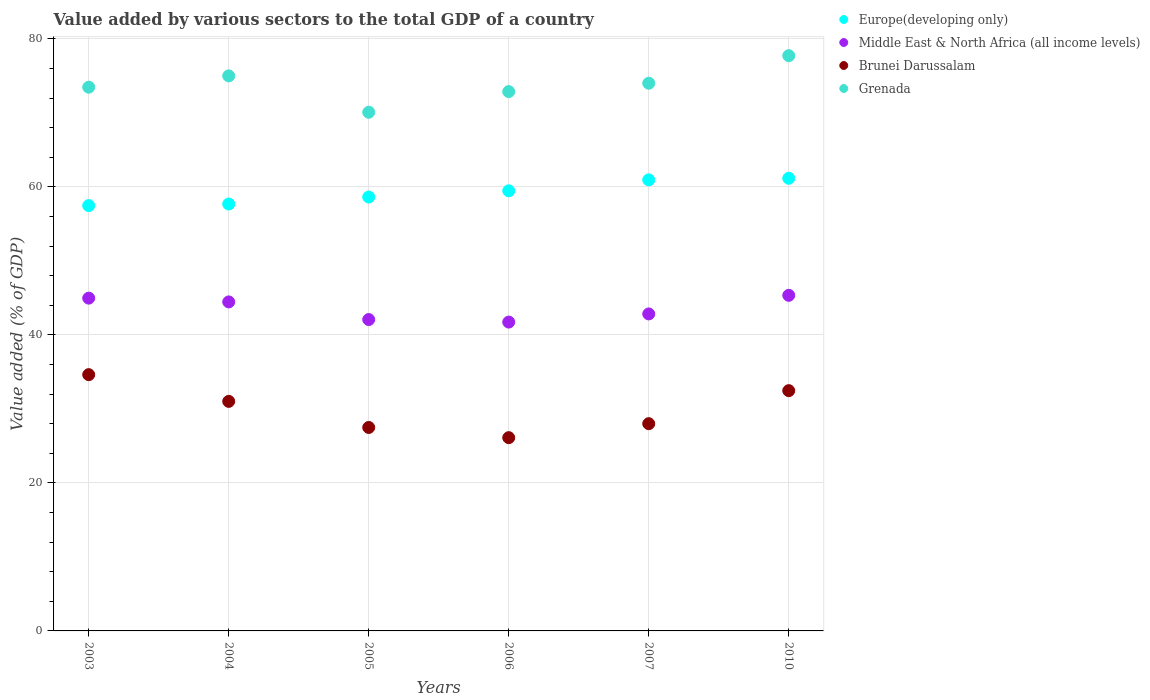Is the number of dotlines equal to the number of legend labels?
Make the answer very short. Yes. What is the value added by various sectors to the total GDP in Middle East & North Africa (all income levels) in 2007?
Your answer should be compact. 42.84. Across all years, what is the maximum value added by various sectors to the total GDP in Middle East & North Africa (all income levels)?
Offer a terse response. 45.35. Across all years, what is the minimum value added by various sectors to the total GDP in Europe(developing only)?
Make the answer very short. 57.48. In which year was the value added by various sectors to the total GDP in Grenada minimum?
Your answer should be very brief. 2005. What is the total value added by various sectors to the total GDP in Europe(developing only) in the graph?
Keep it short and to the point. 355.39. What is the difference between the value added by various sectors to the total GDP in Grenada in 2004 and that in 2006?
Give a very brief answer. 2.12. What is the difference between the value added by various sectors to the total GDP in Brunei Darussalam in 2003 and the value added by various sectors to the total GDP in Grenada in 2005?
Keep it short and to the point. -35.46. What is the average value added by various sectors to the total GDP in Grenada per year?
Keep it short and to the point. 73.87. In the year 2007, what is the difference between the value added by various sectors to the total GDP in Grenada and value added by various sectors to the total GDP in Europe(developing only)?
Give a very brief answer. 13.06. What is the ratio of the value added by various sectors to the total GDP in Middle East & North Africa (all income levels) in 2003 to that in 2005?
Offer a very short reply. 1.07. What is the difference between the highest and the second highest value added by various sectors to the total GDP in Europe(developing only)?
Make the answer very short. 0.21. What is the difference between the highest and the lowest value added by various sectors to the total GDP in Europe(developing only)?
Provide a succinct answer. 3.69. In how many years, is the value added by various sectors to the total GDP in Grenada greater than the average value added by various sectors to the total GDP in Grenada taken over all years?
Provide a short and direct response. 3. Is the sum of the value added by various sectors to the total GDP in Middle East & North Africa (all income levels) in 2005 and 2006 greater than the maximum value added by various sectors to the total GDP in Brunei Darussalam across all years?
Make the answer very short. Yes. Is it the case that in every year, the sum of the value added by various sectors to the total GDP in Brunei Darussalam and value added by various sectors to the total GDP in Europe(developing only)  is greater than the value added by various sectors to the total GDP in Middle East & North Africa (all income levels)?
Give a very brief answer. Yes. Is the value added by various sectors to the total GDP in Brunei Darussalam strictly greater than the value added by various sectors to the total GDP in Grenada over the years?
Provide a short and direct response. No. Is the value added by various sectors to the total GDP in Middle East & North Africa (all income levels) strictly less than the value added by various sectors to the total GDP in Brunei Darussalam over the years?
Offer a very short reply. No. How many dotlines are there?
Your answer should be very brief. 4. Are the values on the major ticks of Y-axis written in scientific E-notation?
Provide a succinct answer. No. Does the graph contain grids?
Your answer should be compact. Yes. Where does the legend appear in the graph?
Provide a succinct answer. Top right. How many legend labels are there?
Your answer should be very brief. 4. What is the title of the graph?
Provide a succinct answer. Value added by various sectors to the total GDP of a country. What is the label or title of the X-axis?
Provide a succinct answer. Years. What is the label or title of the Y-axis?
Provide a succinct answer. Value added (% of GDP). What is the Value added (% of GDP) in Europe(developing only) in 2003?
Offer a very short reply. 57.48. What is the Value added (% of GDP) of Middle East & North Africa (all income levels) in 2003?
Provide a short and direct response. 44.97. What is the Value added (% of GDP) in Brunei Darussalam in 2003?
Your response must be concise. 34.63. What is the Value added (% of GDP) of Grenada in 2003?
Your answer should be compact. 73.48. What is the Value added (% of GDP) of Europe(developing only) in 2004?
Keep it short and to the point. 57.69. What is the Value added (% of GDP) in Middle East & North Africa (all income levels) in 2004?
Provide a short and direct response. 44.46. What is the Value added (% of GDP) in Brunei Darussalam in 2004?
Make the answer very short. 31.02. What is the Value added (% of GDP) in Grenada in 2004?
Your answer should be compact. 75. What is the Value added (% of GDP) of Europe(developing only) in 2005?
Provide a succinct answer. 58.63. What is the Value added (% of GDP) in Middle East & North Africa (all income levels) in 2005?
Provide a short and direct response. 42.08. What is the Value added (% of GDP) in Brunei Darussalam in 2005?
Offer a very short reply. 27.49. What is the Value added (% of GDP) in Grenada in 2005?
Your answer should be compact. 70.09. What is the Value added (% of GDP) of Europe(developing only) in 2006?
Ensure brevity in your answer.  59.47. What is the Value added (% of GDP) of Middle East & North Africa (all income levels) in 2006?
Ensure brevity in your answer.  41.73. What is the Value added (% of GDP) of Brunei Darussalam in 2006?
Your answer should be very brief. 26.12. What is the Value added (% of GDP) in Grenada in 2006?
Make the answer very short. 72.88. What is the Value added (% of GDP) in Europe(developing only) in 2007?
Your response must be concise. 60.95. What is the Value added (% of GDP) of Middle East & North Africa (all income levels) in 2007?
Your answer should be very brief. 42.84. What is the Value added (% of GDP) of Brunei Darussalam in 2007?
Your answer should be compact. 28.01. What is the Value added (% of GDP) of Grenada in 2007?
Keep it short and to the point. 74.01. What is the Value added (% of GDP) in Europe(developing only) in 2010?
Make the answer very short. 61.17. What is the Value added (% of GDP) in Middle East & North Africa (all income levels) in 2010?
Make the answer very short. 45.35. What is the Value added (% of GDP) in Brunei Darussalam in 2010?
Provide a succinct answer. 32.47. What is the Value added (% of GDP) of Grenada in 2010?
Provide a succinct answer. 77.73. Across all years, what is the maximum Value added (% of GDP) of Europe(developing only)?
Your answer should be compact. 61.17. Across all years, what is the maximum Value added (% of GDP) in Middle East & North Africa (all income levels)?
Your answer should be compact. 45.35. Across all years, what is the maximum Value added (% of GDP) of Brunei Darussalam?
Your answer should be compact. 34.63. Across all years, what is the maximum Value added (% of GDP) of Grenada?
Your answer should be compact. 77.73. Across all years, what is the minimum Value added (% of GDP) in Europe(developing only)?
Offer a terse response. 57.48. Across all years, what is the minimum Value added (% of GDP) in Middle East & North Africa (all income levels)?
Ensure brevity in your answer.  41.73. Across all years, what is the minimum Value added (% of GDP) of Brunei Darussalam?
Your answer should be compact. 26.12. Across all years, what is the minimum Value added (% of GDP) in Grenada?
Offer a very short reply. 70.09. What is the total Value added (% of GDP) of Europe(developing only) in the graph?
Offer a terse response. 355.39. What is the total Value added (% of GDP) of Middle East & North Africa (all income levels) in the graph?
Provide a short and direct response. 261.43. What is the total Value added (% of GDP) in Brunei Darussalam in the graph?
Your answer should be very brief. 179.73. What is the total Value added (% of GDP) in Grenada in the graph?
Your answer should be very brief. 443.19. What is the difference between the Value added (% of GDP) of Europe(developing only) in 2003 and that in 2004?
Provide a short and direct response. -0.21. What is the difference between the Value added (% of GDP) in Middle East & North Africa (all income levels) in 2003 and that in 2004?
Your answer should be compact. 0.51. What is the difference between the Value added (% of GDP) of Brunei Darussalam in 2003 and that in 2004?
Provide a short and direct response. 3.61. What is the difference between the Value added (% of GDP) in Grenada in 2003 and that in 2004?
Give a very brief answer. -1.53. What is the difference between the Value added (% of GDP) in Europe(developing only) in 2003 and that in 2005?
Give a very brief answer. -1.16. What is the difference between the Value added (% of GDP) of Middle East & North Africa (all income levels) in 2003 and that in 2005?
Make the answer very short. 2.89. What is the difference between the Value added (% of GDP) of Brunei Darussalam in 2003 and that in 2005?
Make the answer very short. 7.14. What is the difference between the Value added (% of GDP) of Grenada in 2003 and that in 2005?
Your answer should be very brief. 3.39. What is the difference between the Value added (% of GDP) of Europe(developing only) in 2003 and that in 2006?
Keep it short and to the point. -2. What is the difference between the Value added (% of GDP) of Middle East & North Africa (all income levels) in 2003 and that in 2006?
Your response must be concise. 3.24. What is the difference between the Value added (% of GDP) in Brunei Darussalam in 2003 and that in 2006?
Keep it short and to the point. 8.51. What is the difference between the Value added (% of GDP) in Grenada in 2003 and that in 2006?
Provide a succinct answer. 0.6. What is the difference between the Value added (% of GDP) in Europe(developing only) in 2003 and that in 2007?
Your answer should be very brief. -3.48. What is the difference between the Value added (% of GDP) in Middle East & North Africa (all income levels) in 2003 and that in 2007?
Offer a very short reply. 2.13. What is the difference between the Value added (% of GDP) in Brunei Darussalam in 2003 and that in 2007?
Make the answer very short. 6.62. What is the difference between the Value added (% of GDP) of Grenada in 2003 and that in 2007?
Offer a very short reply. -0.53. What is the difference between the Value added (% of GDP) of Europe(developing only) in 2003 and that in 2010?
Provide a succinct answer. -3.69. What is the difference between the Value added (% of GDP) of Middle East & North Africa (all income levels) in 2003 and that in 2010?
Keep it short and to the point. -0.38. What is the difference between the Value added (% of GDP) in Brunei Darussalam in 2003 and that in 2010?
Offer a very short reply. 2.16. What is the difference between the Value added (% of GDP) of Grenada in 2003 and that in 2010?
Ensure brevity in your answer.  -4.26. What is the difference between the Value added (% of GDP) in Europe(developing only) in 2004 and that in 2005?
Offer a terse response. -0.95. What is the difference between the Value added (% of GDP) of Middle East & North Africa (all income levels) in 2004 and that in 2005?
Keep it short and to the point. 2.38. What is the difference between the Value added (% of GDP) in Brunei Darussalam in 2004 and that in 2005?
Ensure brevity in your answer.  3.53. What is the difference between the Value added (% of GDP) in Grenada in 2004 and that in 2005?
Your response must be concise. 4.92. What is the difference between the Value added (% of GDP) of Europe(developing only) in 2004 and that in 2006?
Make the answer very short. -1.79. What is the difference between the Value added (% of GDP) of Middle East & North Africa (all income levels) in 2004 and that in 2006?
Give a very brief answer. 2.73. What is the difference between the Value added (% of GDP) of Brunei Darussalam in 2004 and that in 2006?
Your answer should be compact. 4.9. What is the difference between the Value added (% of GDP) in Grenada in 2004 and that in 2006?
Keep it short and to the point. 2.12. What is the difference between the Value added (% of GDP) of Europe(developing only) in 2004 and that in 2007?
Your response must be concise. -3.27. What is the difference between the Value added (% of GDP) in Middle East & North Africa (all income levels) in 2004 and that in 2007?
Offer a very short reply. 1.62. What is the difference between the Value added (% of GDP) of Brunei Darussalam in 2004 and that in 2007?
Make the answer very short. 3.01. What is the difference between the Value added (% of GDP) in Europe(developing only) in 2004 and that in 2010?
Offer a very short reply. -3.48. What is the difference between the Value added (% of GDP) in Middle East & North Africa (all income levels) in 2004 and that in 2010?
Make the answer very short. -0.89. What is the difference between the Value added (% of GDP) of Brunei Darussalam in 2004 and that in 2010?
Make the answer very short. -1.45. What is the difference between the Value added (% of GDP) in Grenada in 2004 and that in 2010?
Ensure brevity in your answer.  -2.73. What is the difference between the Value added (% of GDP) in Europe(developing only) in 2005 and that in 2006?
Your answer should be very brief. -0.84. What is the difference between the Value added (% of GDP) of Middle East & North Africa (all income levels) in 2005 and that in 2006?
Keep it short and to the point. 0.34. What is the difference between the Value added (% of GDP) in Brunei Darussalam in 2005 and that in 2006?
Offer a very short reply. 1.38. What is the difference between the Value added (% of GDP) in Grenada in 2005 and that in 2006?
Offer a terse response. -2.79. What is the difference between the Value added (% of GDP) of Europe(developing only) in 2005 and that in 2007?
Provide a short and direct response. -2.32. What is the difference between the Value added (% of GDP) in Middle East & North Africa (all income levels) in 2005 and that in 2007?
Provide a succinct answer. -0.76. What is the difference between the Value added (% of GDP) in Brunei Darussalam in 2005 and that in 2007?
Make the answer very short. -0.51. What is the difference between the Value added (% of GDP) of Grenada in 2005 and that in 2007?
Give a very brief answer. -3.92. What is the difference between the Value added (% of GDP) in Europe(developing only) in 2005 and that in 2010?
Your answer should be very brief. -2.53. What is the difference between the Value added (% of GDP) in Middle East & North Africa (all income levels) in 2005 and that in 2010?
Keep it short and to the point. -3.27. What is the difference between the Value added (% of GDP) of Brunei Darussalam in 2005 and that in 2010?
Your response must be concise. -4.97. What is the difference between the Value added (% of GDP) of Grenada in 2005 and that in 2010?
Ensure brevity in your answer.  -7.65. What is the difference between the Value added (% of GDP) of Europe(developing only) in 2006 and that in 2007?
Provide a short and direct response. -1.48. What is the difference between the Value added (% of GDP) in Middle East & North Africa (all income levels) in 2006 and that in 2007?
Your answer should be compact. -1.1. What is the difference between the Value added (% of GDP) of Brunei Darussalam in 2006 and that in 2007?
Keep it short and to the point. -1.89. What is the difference between the Value added (% of GDP) in Grenada in 2006 and that in 2007?
Provide a succinct answer. -1.13. What is the difference between the Value added (% of GDP) of Europe(developing only) in 2006 and that in 2010?
Ensure brevity in your answer.  -1.69. What is the difference between the Value added (% of GDP) in Middle East & North Africa (all income levels) in 2006 and that in 2010?
Your answer should be compact. -3.62. What is the difference between the Value added (% of GDP) of Brunei Darussalam in 2006 and that in 2010?
Your answer should be compact. -6.35. What is the difference between the Value added (% of GDP) in Grenada in 2006 and that in 2010?
Keep it short and to the point. -4.85. What is the difference between the Value added (% of GDP) in Europe(developing only) in 2007 and that in 2010?
Make the answer very short. -0.21. What is the difference between the Value added (% of GDP) in Middle East & North Africa (all income levels) in 2007 and that in 2010?
Keep it short and to the point. -2.51. What is the difference between the Value added (% of GDP) of Brunei Darussalam in 2007 and that in 2010?
Offer a terse response. -4.46. What is the difference between the Value added (% of GDP) of Grenada in 2007 and that in 2010?
Your answer should be very brief. -3.72. What is the difference between the Value added (% of GDP) in Europe(developing only) in 2003 and the Value added (% of GDP) in Middle East & North Africa (all income levels) in 2004?
Offer a very short reply. 13.02. What is the difference between the Value added (% of GDP) in Europe(developing only) in 2003 and the Value added (% of GDP) in Brunei Darussalam in 2004?
Provide a succinct answer. 26.46. What is the difference between the Value added (% of GDP) of Europe(developing only) in 2003 and the Value added (% of GDP) of Grenada in 2004?
Your answer should be very brief. -17.53. What is the difference between the Value added (% of GDP) of Middle East & North Africa (all income levels) in 2003 and the Value added (% of GDP) of Brunei Darussalam in 2004?
Ensure brevity in your answer.  13.95. What is the difference between the Value added (% of GDP) in Middle East & North Africa (all income levels) in 2003 and the Value added (% of GDP) in Grenada in 2004?
Make the answer very short. -30.03. What is the difference between the Value added (% of GDP) of Brunei Darussalam in 2003 and the Value added (% of GDP) of Grenada in 2004?
Offer a very short reply. -40.37. What is the difference between the Value added (% of GDP) in Europe(developing only) in 2003 and the Value added (% of GDP) in Middle East & North Africa (all income levels) in 2005?
Ensure brevity in your answer.  15.4. What is the difference between the Value added (% of GDP) in Europe(developing only) in 2003 and the Value added (% of GDP) in Brunei Darussalam in 2005?
Your answer should be compact. 29.98. What is the difference between the Value added (% of GDP) of Europe(developing only) in 2003 and the Value added (% of GDP) of Grenada in 2005?
Your answer should be very brief. -12.61. What is the difference between the Value added (% of GDP) in Middle East & North Africa (all income levels) in 2003 and the Value added (% of GDP) in Brunei Darussalam in 2005?
Your response must be concise. 17.48. What is the difference between the Value added (% of GDP) in Middle East & North Africa (all income levels) in 2003 and the Value added (% of GDP) in Grenada in 2005?
Ensure brevity in your answer.  -25.12. What is the difference between the Value added (% of GDP) in Brunei Darussalam in 2003 and the Value added (% of GDP) in Grenada in 2005?
Keep it short and to the point. -35.46. What is the difference between the Value added (% of GDP) in Europe(developing only) in 2003 and the Value added (% of GDP) in Middle East & North Africa (all income levels) in 2006?
Offer a very short reply. 15.74. What is the difference between the Value added (% of GDP) in Europe(developing only) in 2003 and the Value added (% of GDP) in Brunei Darussalam in 2006?
Your answer should be very brief. 31.36. What is the difference between the Value added (% of GDP) of Europe(developing only) in 2003 and the Value added (% of GDP) of Grenada in 2006?
Provide a short and direct response. -15.4. What is the difference between the Value added (% of GDP) in Middle East & North Africa (all income levels) in 2003 and the Value added (% of GDP) in Brunei Darussalam in 2006?
Offer a terse response. 18.85. What is the difference between the Value added (% of GDP) of Middle East & North Africa (all income levels) in 2003 and the Value added (% of GDP) of Grenada in 2006?
Ensure brevity in your answer.  -27.91. What is the difference between the Value added (% of GDP) in Brunei Darussalam in 2003 and the Value added (% of GDP) in Grenada in 2006?
Ensure brevity in your answer.  -38.25. What is the difference between the Value added (% of GDP) of Europe(developing only) in 2003 and the Value added (% of GDP) of Middle East & North Africa (all income levels) in 2007?
Your answer should be compact. 14.64. What is the difference between the Value added (% of GDP) of Europe(developing only) in 2003 and the Value added (% of GDP) of Brunei Darussalam in 2007?
Make the answer very short. 29.47. What is the difference between the Value added (% of GDP) in Europe(developing only) in 2003 and the Value added (% of GDP) in Grenada in 2007?
Keep it short and to the point. -16.53. What is the difference between the Value added (% of GDP) of Middle East & North Africa (all income levels) in 2003 and the Value added (% of GDP) of Brunei Darussalam in 2007?
Make the answer very short. 16.96. What is the difference between the Value added (% of GDP) in Middle East & North Africa (all income levels) in 2003 and the Value added (% of GDP) in Grenada in 2007?
Your answer should be very brief. -29.04. What is the difference between the Value added (% of GDP) of Brunei Darussalam in 2003 and the Value added (% of GDP) of Grenada in 2007?
Make the answer very short. -39.38. What is the difference between the Value added (% of GDP) of Europe(developing only) in 2003 and the Value added (% of GDP) of Middle East & North Africa (all income levels) in 2010?
Your response must be concise. 12.13. What is the difference between the Value added (% of GDP) of Europe(developing only) in 2003 and the Value added (% of GDP) of Brunei Darussalam in 2010?
Keep it short and to the point. 25.01. What is the difference between the Value added (% of GDP) in Europe(developing only) in 2003 and the Value added (% of GDP) in Grenada in 2010?
Your answer should be very brief. -20.26. What is the difference between the Value added (% of GDP) in Middle East & North Africa (all income levels) in 2003 and the Value added (% of GDP) in Brunei Darussalam in 2010?
Keep it short and to the point. 12.5. What is the difference between the Value added (% of GDP) in Middle East & North Africa (all income levels) in 2003 and the Value added (% of GDP) in Grenada in 2010?
Your answer should be compact. -32.77. What is the difference between the Value added (% of GDP) of Brunei Darussalam in 2003 and the Value added (% of GDP) of Grenada in 2010?
Offer a very short reply. -43.1. What is the difference between the Value added (% of GDP) of Europe(developing only) in 2004 and the Value added (% of GDP) of Middle East & North Africa (all income levels) in 2005?
Offer a terse response. 15.61. What is the difference between the Value added (% of GDP) of Europe(developing only) in 2004 and the Value added (% of GDP) of Brunei Darussalam in 2005?
Make the answer very short. 30.19. What is the difference between the Value added (% of GDP) in Europe(developing only) in 2004 and the Value added (% of GDP) in Grenada in 2005?
Your answer should be compact. -12.4. What is the difference between the Value added (% of GDP) of Middle East & North Africa (all income levels) in 2004 and the Value added (% of GDP) of Brunei Darussalam in 2005?
Give a very brief answer. 16.97. What is the difference between the Value added (% of GDP) in Middle East & North Africa (all income levels) in 2004 and the Value added (% of GDP) in Grenada in 2005?
Your answer should be very brief. -25.63. What is the difference between the Value added (% of GDP) of Brunei Darussalam in 2004 and the Value added (% of GDP) of Grenada in 2005?
Make the answer very short. -39.07. What is the difference between the Value added (% of GDP) of Europe(developing only) in 2004 and the Value added (% of GDP) of Middle East & North Africa (all income levels) in 2006?
Your response must be concise. 15.95. What is the difference between the Value added (% of GDP) of Europe(developing only) in 2004 and the Value added (% of GDP) of Brunei Darussalam in 2006?
Offer a terse response. 31.57. What is the difference between the Value added (% of GDP) of Europe(developing only) in 2004 and the Value added (% of GDP) of Grenada in 2006?
Offer a terse response. -15.19. What is the difference between the Value added (% of GDP) in Middle East & North Africa (all income levels) in 2004 and the Value added (% of GDP) in Brunei Darussalam in 2006?
Your response must be concise. 18.34. What is the difference between the Value added (% of GDP) of Middle East & North Africa (all income levels) in 2004 and the Value added (% of GDP) of Grenada in 2006?
Your response must be concise. -28.42. What is the difference between the Value added (% of GDP) in Brunei Darussalam in 2004 and the Value added (% of GDP) in Grenada in 2006?
Provide a succinct answer. -41.86. What is the difference between the Value added (% of GDP) in Europe(developing only) in 2004 and the Value added (% of GDP) in Middle East & North Africa (all income levels) in 2007?
Keep it short and to the point. 14.85. What is the difference between the Value added (% of GDP) of Europe(developing only) in 2004 and the Value added (% of GDP) of Brunei Darussalam in 2007?
Offer a very short reply. 29.68. What is the difference between the Value added (% of GDP) in Europe(developing only) in 2004 and the Value added (% of GDP) in Grenada in 2007?
Keep it short and to the point. -16.32. What is the difference between the Value added (% of GDP) of Middle East & North Africa (all income levels) in 2004 and the Value added (% of GDP) of Brunei Darussalam in 2007?
Provide a succinct answer. 16.45. What is the difference between the Value added (% of GDP) in Middle East & North Africa (all income levels) in 2004 and the Value added (% of GDP) in Grenada in 2007?
Provide a short and direct response. -29.55. What is the difference between the Value added (% of GDP) of Brunei Darussalam in 2004 and the Value added (% of GDP) of Grenada in 2007?
Your answer should be very brief. -42.99. What is the difference between the Value added (% of GDP) in Europe(developing only) in 2004 and the Value added (% of GDP) in Middle East & North Africa (all income levels) in 2010?
Offer a terse response. 12.34. What is the difference between the Value added (% of GDP) in Europe(developing only) in 2004 and the Value added (% of GDP) in Brunei Darussalam in 2010?
Your answer should be very brief. 25.22. What is the difference between the Value added (% of GDP) of Europe(developing only) in 2004 and the Value added (% of GDP) of Grenada in 2010?
Your response must be concise. -20.05. What is the difference between the Value added (% of GDP) in Middle East & North Africa (all income levels) in 2004 and the Value added (% of GDP) in Brunei Darussalam in 2010?
Offer a terse response. 11.99. What is the difference between the Value added (% of GDP) in Middle East & North Africa (all income levels) in 2004 and the Value added (% of GDP) in Grenada in 2010?
Your answer should be compact. -33.27. What is the difference between the Value added (% of GDP) of Brunei Darussalam in 2004 and the Value added (% of GDP) of Grenada in 2010?
Ensure brevity in your answer.  -46.72. What is the difference between the Value added (% of GDP) of Europe(developing only) in 2005 and the Value added (% of GDP) of Middle East & North Africa (all income levels) in 2006?
Offer a terse response. 16.9. What is the difference between the Value added (% of GDP) in Europe(developing only) in 2005 and the Value added (% of GDP) in Brunei Darussalam in 2006?
Make the answer very short. 32.52. What is the difference between the Value added (% of GDP) of Europe(developing only) in 2005 and the Value added (% of GDP) of Grenada in 2006?
Your answer should be compact. -14.25. What is the difference between the Value added (% of GDP) of Middle East & North Africa (all income levels) in 2005 and the Value added (% of GDP) of Brunei Darussalam in 2006?
Provide a succinct answer. 15.96. What is the difference between the Value added (% of GDP) of Middle East & North Africa (all income levels) in 2005 and the Value added (% of GDP) of Grenada in 2006?
Your answer should be compact. -30.8. What is the difference between the Value added (% of GDP) in Brunei Darussalam in 2005 and the Value added (% of GDP) in Grenada in 2006?
Your response must be concise. -45.39. What is the difference between the Value added (% of GDP) in Europe(developing only) in 2005 and the Value added (% of GDP) in Middle East & North Africa (all income levels) in 2007?
Your response must be concise. 15.8. What is the difference between the Value added (% of GDP) of Europe(developing only) in 2005 and the Value added (% of GDP) of Brunei Darussalam in 2007?
Ensure brevity in your answer.  30.63. What is the difference between the Value added (% of GDP) of Europe(developing only) in 2005 and the Value added (% of GDP) of Grenada in 2007?
Your answer should be very brief. -15.38. What is the difference between the Value added (% of GDP) of Middle East & North Africa (all income levels) in 2005 and the Value added (% of GDP) of Brunei Darussalam in 2007?
Make the answer very short. 14.07. What is the difference between the Value added (% of GDP) of Middle East & North Africa (all income levels) in 2005 and the Value added (% of GDP) of Grenada in 2007?
Offer a very short reply. -31.93. What is the difference between the Value added (% of GDP) of Brunei Darussalam in 2005 and the Value added (% of GDP) of Grenada in 2007?
Your response must be concise. -46.52. What is the difference between the Value added (% of GDP) of Europe(developing only) in 2005 and the Value added (% of GDP) of Middle East & North Africa (all income levels) in 2010?
Give a very brief answer. 13.28. What is the difference between the Value added (% of GDP) in Europe(developing only) in 2005 and the Value added (% of GDP) in Brunei Darussalam in 2010?
Offer a very short reply. 26.17. What is the difference between the Value added (% of GDP) in Europe(developing only) in 2005 and the Value added (% of GDP) in Grenada in 2010?
Ensure brevity in your answer.  -19.1. What is the difference between the Value added (% of GDP) of Middle East & North Africa (all income levels) in 2005 and the Value added (% of GDP) of Brunei Darussalam in 2010?
Provide a succinct answer. 9.61. What is the difference between the Value added (% of GDP) of Middle East & North Africa (all income levels) in 2005 and the Value added (% of GDP) of Grenada in 2010?
Provide a succinct answer. -35.66. What is the difference between the Value added (% of GDP) of Brunei Darussalam in 2005 and the Value added (% of GDP) of Grenada in 2010?
Ensure brevity in your answer.  -50.24. What is the difference between the Value added (% of GDP) in Europe(developing only) in 2006 and the Value added (% of GDP) in Middle East & North Africa (all income levels) in 2007?
Keep it short and to the point. 16.64. What is the difference between the Value added (% of GDP) of Europe(developing only) in 2006 and the Value added (% of GDP) of Brunei Darussalam in 2007?
Keep it short and to the point. 31.47. What is the difference between the Value added (% of GDP) of Europe(developing only) in 2006 and the Value added (% of GDP) of Grenada in 2007?
Offer a very short reply. -14.54. What is the difference between the Value added (% of GDP) in Middle East & North Africa (all income levels) in 2006 and the Value added (% of GDP) in Brunei Darussalam in 2007?
Offer a very short reply. 13.73. What is the difference between the Value added (% of GDP) in Middle East & North Africa (all income levels) in 2006 and the Value added (% of GDP) in Grenada in 2007?
Offer a very short reply. -32.28. What is the difference between the Value added (% of GDP) of Brunei Darussalam in 2006 and the Value added (% of GDP) of Grenada in 2007?
Make the answer very short. -47.89. What is the difference between the Value added (% of GDP) in Europe(developing only) in 2006 and the Value added (% of GDP) in Middle East & North Africa (all income levels) in 2010?
Offer a terse response. 14.12. What is the difference between the Value added (% of GDP) in Europe(developing only) in 2006 and the Value added (% of GDP) in Brunei Darussalam in 2010?
Your answer should be very brief. 27.01. What is the difference between the Value added (% of GDP) in Europe(developing only) in 2006 and the Value added (% of GDP) in Grenada in 2010?
Ensure brevity in your answer.  -18.26. What is the difference between the Value added (% of GDP) of Middle East & North Africa (all income levels) in 2006 and the Value added (% of GDP) of Brunei Darussalam in 2010?
Make the answer very short. 9.27. What is the difference between the Value added (% of GDP) in Middle East & North Africa (all income levels) in 2006 and the Value added (% of GDP) in Grenada in 2010?
Your response must be concise. -36. What is the difference between the Value added (% of GDP) of Brunei Darussalam in 2006 and the Value added (% of GDP) of Grenada in 2010?
Provide a succinct answer. -51.62. What is the difference between the Value added (% of GDP) of Europe(developing only) in 2007 and the Value added (% of GDP) of Middle East & North Africa (all income levels) in 2010?
Keep it short and to the point. 15.6. What is the difference between the Value added (% of GDP) of Europe(developing only) in 2007 and the Value added (% of GDP) of Brunei Darussalam in 2010?
Make the answer very short. 28.49. What is the difference between the Value added (% of GDP) of Europe(developing only) in 2007 and the Value added (% of GDP) of Grenada in 2010?
Keep it short and to the point. -16.78. What is the difference between the Value added (% of GDP) of Middle East & North Africa (all income levels) in 2007 and the Value added (% of GDP) of Brunei Darussalam in 2010?
Provide a short and direct response. 10.37. What is the difference between the Value added (% of GDP) in Middle East & North Africa (all income levels) in 2007 and the Value added (% of GDP) in Grenada in 2010?
Your answer should be very brief. -34.9. What is the difference between the Value added (% of GDP) in Brunei Darussalam in 2007 and the Value added (% of GDP) in Grenada in 2010?
Offer a terse response. -49.73. What is the average Value added (% of GDP) of Europe(developing only) per year?
Your answer should be compact. 59.23. What is the average Value added (% of GDP) in Middle East & North Africa (all income levels) per year?
Make the answer very short. 43.57. What is the average Value added (% of GDP) in Brunei Darussalam per year?
Give a very brief answer. 29.96. What is the average Value added (% of GDP) in Grenada per year?
Keep it short and to the point. 73.87. In the year 2003, what is the difference between the Value added (% of GDP) of Europe(developing only) and Value added (% of GDP) of Middle East & North Africa (all income levels)?
Give a very brief answer. 12.51. In the year 2003, what is the difference between the Value added (% of GDP) in Europe(developing only) and Value added (% of GDP) in Brunei Darussalam?
Give a very brief answer. 22.85. In the year 2003, what is the difference between the Value added (% of GDP) in Europe(developing only) and Value added (% of GDP) in Grenada?
Offer a very short reply. -16. In the year 2003, what is the difference between the Value added (% of GDP) of Middle East & North Africa (all income levels) and Value added (% of GDP) of Brunei Darussalam?
Give a very brief answer. 10.34. In the year 2003, what is the difference between the Value added (% of GDP) in Middle East & North Africa (all income levels) and Value added (% of GDP) in Grenada?
Offer a very short reply. -28.51. In the year 2003, what is the difference between the Value added (% of GDP) of Brunei Darussalam and Value added (% of GDP) of Grenada?
Offer a terse response. -38.85. In the year 2004, what is the difference between the Value added (% of GDP) in Europe(developing only) and Value added (% of GDP) in Middle East & North Africa (all income levels)?
Your answer should be compact. 13.23. In the year 2004, what is the difference between the Value added (% of GDP) in Europe(developing only) and Value added (% of GDP) in Brunei Darussalam?
Your answer should be compact. 26.67. In the year 2004, what is the difference between the Value added (% of GDP) in Europe(developing only) and Value added (% of GDP) in Grenada?
Offer a very short reply. -17.32. In the year 2004, what is the difference between the Value added (% of GDP) in Middle East & North Africa (all income levels) and Value added (% of GDP) in Brunei Darussalam?
Make the answer very short. 13.44. In the year 2004, what is the difference between the Value added (% of GDP) of Middle East & North Africa (all income levels) and Value added (% of GDP) of Grenada?
Offer a terse response. -30.54. In the year 2004, what is the difference between the Value added (% of GDP) in Brunei Darussalam and Value added (% of GDP) in Grenada?
Offer a very short reply. -43.98. In the year 2005, what is the difference between the Value added (% of GDP) of Europe(developing only) and Value added (% of GDP) of Middle East & North Africa (all income levels)?
Ensure brevity in your answer.  16.56. In the year 2005, what is the difference between the Value added (% of GDP) of Europe(developing only) and Value added (% of GDP) of Brunei Darussalam?
Give a very brief answer. 31.14. In the year 2005, what is the difference between the Value added (% of GDP) of Europe(developing only) and Value added (% of GDP) of Grenada?
Give a very brief answer. -11.45. In the year 2005, what is the difference between the Value added (% of GDP) in Middle East & North Africa (all income levels) and Value added (% of GDP) in Brunei Darussalam?
Ensure brevity in your answer.  14.58. In the year 2005, what is the difference between the Value added (% of GDP) of Middle East & North Africa (all income levels) and Value added (% of GDP) of Grenada?
Provide a short and direct response. -28.01. In the year 2005, what is the difference between the Value added (% of GDP) of Brunei Darussalam and Value added (% of GDP) of Grenada?
Keep it short and to the point. -42.59. In the year 2006, what is the difference between the Value added (% of GDP) of Europe(developing only) and Value added (% of GDP) of Middle East & North Africa (all income levels)?
Ensure brevity in your answer.  17.74. In the year 2006, what is the difference between the Value added (% of GDP) in Europe(developing only) and Value added (% of GDP) in Brunei Darussalam?
Give a very brief answer. 33.36. In the year 2006, what is the difference between the Value added (% of GDP) of Europe(developing only) and Value added (% of GDP) of Grenada?
Your response must be concise. -13.41. In the year 2006, what is the difference between the Value added (% of GDP) in Middle East & North Africa (all income levels) and Value added (% of GDP) in Brunei Darussalam?
Your response must be concise. 15.62. In the year 2006, what is the difference between the Value added (% of GDP) in Middle East & North Africa (all income levels) and Value added (% of GDP) in Grenada?
Provide a short and direct response. -31.15. In the year 2006, what is the difference between the Value added (% of GDP) in Brunei Darussalam and Value added (% of GDP) in Grenada?
Provide a succinct answer. -46.76. In the year 2007, what is the difference between the Value added (% of GDP) of Europe(developing only) and Value added (% of GDP) of Middle East & North Africa (all income levels)?
Ensure brevity in your answer.  18.12. In the year 2007, what is the difference between the Value added (% of GDP) of Europe(developing only) and Value added (% of GDP) of Brunei Darussalam?
Make the answer very short. 32.95. In the year 2007, what is the difference between the Value added (% of GDP) of Europe(developing only) and Value added (% of GDP) of Grenada?
Give a very brief answer. -13.06. In the year 2007, what is the difference between the Value added (% of GDP) of Middle East & North Africa (all income levels) and Value added (% of GDP) of Brunei Darussalam?
Your response must be concise. 14.83. In the year 2007, what is the difference between the Value added (% of GDP) of Middle East & North Africa (all income levels) and Value added (% of GDP) of Grenada?
Your answer should be compact. -31.18. In the year 2007, what is the difference between the Value added (% of GDP) of Brunei Darussalam and Value added (% of GDP) of Grenada?
Your answer should be compact. -46.01. In the year 2010, what is the difference between the Value added (% of GDP) in Europe(developing only) and Value added (% of GDP) in Middle East & North Africa (all income levels)?
Ensure brevity in your answer.  15.82. In the year 2010, what is the difference between the Value added (% of GDP) in Europe(developing only) and Value added (% of GDP) in Brunei Darussalam?
Give a very brief answer. 28.7. In the year 2010, what is the difference between the Value added (% of GDP) in Europe(developing only) and Value added (% of GDP) in Grenada?
Keep it short and to the point. -16.57. In the year 2010, what is the difference between the Value added (% of GDP) of Middle East & North Africa (all income levels) and Value added (% of GDP) of Brunei Darussalam?
Provide a short and direct response. 12.88. In the year 2010, what is the difference between the Value added (% of GDP) in Middle East & North Africa (all income levels) and Value added (% of GDP) in Grenada?
Give a very brief answer. -32.38. In the year 2010, what is the difference between the Value added (% of GDP) in Brunei Darussalam and Value added (% of GDP) in Grenada?
Give a very brief answer. -45.27. What is the ratio of the Value added (% of GDP) of Europe(developing only) in 2003 to that in 2004?
Your response must be concise. 1. What is the ratio of the Value added (% of GDP) of Middle East & North Africa (all income levels) in 2003 to that in 2004?
Provide a short and direct response. 1.01. What is the ratio of the Value added (% of GDP) in Brunei Darussalam in 2003 to that in 2004?
Provide a succinct answer. 1.12. What is the ratio of the Value added (% of GDP) of Grenada in 2003 to that in 2004?
Keep it short and to the point. 0.98. What is the ratio of the Value added (% of GDP) in Europe(developing only) in 2003 to that in 2005?
Keep it short and to the point. 0.98. What is the ratio of the Value added (% of GDP) in Middle East & North Africa (all income levels) in 2003 to that in 2005?
Keep it short and to the point. 1.07. What is the ratio of the Value added (% of GDP) in Brunei Darussalam in 2003 to that in 2005?
Your response must be concise. 1.26. What is the ratio of the Value added (% of GDP) of Grenada in 2003 to that in 2005?
Give a very brief answer. 1.05. What is the ratio of the Value added (% of GDP) of Europe(developing only) in 2003 to that in 2006?
Keep it short and to the point. 0.97. What is the ratio of the Value added (% of GDP) in Middle East & North Africa (all income levels) in 2003 to that in 2006?
Your answer should be compact. 1.08. What is the ratio of the Value added (% of GDP) of Brunei Darussalam in 2003 to that in 2006?
Provide a short and direct response. 1.33. What is the ratio of the Value added (% of GDP) in Grenada in 2003 to that in 2006?
Ensure brevity in your answer.  1.01. What is the ratio of the Value added (% of GDP) of Europe(developing only) in 2003 to that in 2007?
Give a very brief answer. 0.94. What is the ratio of the Value added (% of GDP) in Middle East & North Africa (all income levels) in 2003 to that in 2007?
Provide a short and direct response. 1.05. What is the ratio of the Value added (% of GDP) of Brunei Darussalam in 2003 to that in 2007?
Make the answer very short. 1.24. What is the ratio of the Value added (% of GDP) of Grenada in 2003 to that in 2007?
Your response must be concise. 0.99. What is the ratio of the Value added (% of GDP) of Europe(developing only) in 2003 to that in 2010?
Your response must be concise. 0.94. What is the ratio of the Value added (% of GDP) of Brunei Darussalam in 2003 to that in 2010?
Provide a short and direct response. 1.07. What is the ratio of the Value added (% of GDP) of Grenada in 2003 to that in 2010?
Give a very brief answer. 0.95. What is the ratio of the Value added (% of GDP) in Europe(developing only) in 2004 to that in 2005?
Provide a short and direct response. 0.98. What is the ratio of the Value added (% of GDP) of Middle East & North Africa (all income levels) in 2004 to that in 2005?
Your answer should be compact. 1.06. What is the ratio of the Value added (% of GDP) in Brunei Darussalam in 2004 to that in 2005?
Provide a short and direct response. 1.13. What is the ratio of the Value added (% of GDP) of Grenada in 2004 to that in 2005?
Your answer should be compact. 1.07. What is the ratio of the Value added (% of GDP) of Middle East & North Africa (all income levels) in 2004 to that in 2006?
Give a very brief answer. 1.07. What is the ratio of the Value added (% of GDP) in Brunei Darussalam in 2004 to that in 2006?
Your answer should be compact. 1.19. What is the ratio of the Value added (% of GDP) of Grenada in 2004 to that in 2006?
Keep it short and to the point. 1.03. What is the ratio of the Value added (% of GDP) of Europe(developing only) in 2004 to that in 2007?
Offer a terse response. 0.95. What is the ratio of the Value added (% of GDP) in Middle East & North Africa (all income levels) in 2004 to that in 2007?
Your answer should be compact. 1.04. What is the ratio of the Value added (% of GDP) of Brunei Darussalam in 2004 to that in 2007?
Your answer should be compact. 1.11. What is the ratio of the Value added (% of GDP) of Grenada in 2004 to that in 2007?
Your answer should be very brief. 1.01. What is the ratio of the Value added (% of GDP) of Europe(developing only) in 2004 to that in 2010?
Provide a short and direct response. 0.94. What is the ratio of the Value added (% of GDP) of Middle East & North Africa (all income levels) in 2004 to that in 2010?
Provide a short and direct response. 0.98. What is the ratio of the Value added (% of GDP) in Brunei Darussalam in 2004 to that in 2010?
Make the answer very short. 0.96. What is the ratio of the Value added (% of GDP) in Grenada in 2004 to that in 2010?
Provide a short and direct response. 0.96. What is the ratio of the Value added (% of GDP) in Europe(developing only) in 2005 to that in 2006?
Give a very brief answer. 0.99. What is the ratio of the Value added (% of GDP) in Middle East & North Africa (all income levels) in 2005 to that in 2006?
Your answer should be compact. 1.01. What is the ratio of the Value added (% of GDP) in Brunei Darussalam in 2005 to that in 2006?
Offer a terse response. 1.05. What is the ratio of the Value added (% of GDP) in Grenada in 2005 to that in 2006?
Provide a succinct answer. 0.96. What is the ratio of the Value added (% of GDP) in Europe(developing only) in 2005 to that in 2007?
Provide a short and direct response. 0.96. What is the ratio of the Value added (% of GDP) in Middle East & North Africa (all income levels) in 2005 to that in 2007?
Give a very brief answer. 0.98. What is the ratio of the Value added (% of GDP) in Brunei Darussalam in 2005 to that in 2007?
Your response must be concise. 0.98. What is the ratio of the Value added (% of GDP) of Grenada in 2005 to that in 2007?
Ensure brevity in your answer.  0.95. What is the ratio of the Value added (% of GDP) in Europe(developing only) in 2005 to that in 2010?
Ensure brevity in your answer.  0.96. What is the ratio of the Value added (% of GDP) of Middle East & North Africa (all income levels) in 2005 to that in 2010?
Ensure brevity in your answer.  0.93. What is the ratio of the Value added (% of GDP) of Brunei Darussalam in 2005 to that in 2010?
Provide a succinct answer. 0.85. What is the ratio of the Value added (% of GDP) in Grenada in 2005 to that in 2010?
Offer a very short reply. 0.9. What is the ratio of the Value added (% of GDP) of Europe(developing only) in 2006 to that in 2007?
Offer a very short reply. 0.98. What is the ratio of the Value added (% of GDP) in Middle East & North Africa (all income levels) in 2006 to that in 2007?
Your response must be concise. 0.97. What is the ratio of the Value added (% of GDP) of Brunei Darussalam in 2006 to that in 2007?
Offer a very short reply. 0.93. What is the ratio of the Value added (% of GDP) in Grenada in 2006 to that in 2007?
Keep it short and to the point. 0.98. What is the ratio of the Value added (% of GDP) of Europe(developing only) in 2006 to that in 2010?
Make the answer very short. 0.97. What is the ratio of the Value added (% of GDP) in Middle East & North Africa (all income levels) in 2006 to that in 2010?
Provide a short and direct response. 0.92. What is the ratio of the Value added (% of GDP) in Brunei Darussalam in 2006 to that in 2010?
Your answer should be compact. 0.8. What is the ratio of the Value added (% of GDP) of Grenada in 2006 to that in 2010?
Keep it short and to the point. 0.94. What is the ratio of the Value added (% of GDP) of Europe(developing only) in 2007 to that in 2010?
Offer a very short reply. 1. What is the ratio of the Value added (% of GDP) of Middle East & North Africa (all income levels) in 2007 to that in 2010?
Ensure brevity in your answer.  0.94. What is the ratio of the Value added (% of GDP) of Brunei Darussalam in 2007 to that in 2010?
Your answer should be compact. 0.86. What is the ratio of the Value added (% of GDP) in Grenada in 2007 to that in 2010?
Your response must be concise. 0.95. What is the difference between the highest and the second highest Value added (% of GDP) in Europe(developing only)?
Offer a very short reply. 0.21. What is the difference between the highest and the second highest Value added (% of GDP) of Middle East & North Africa (all income levels)?
Your answer should be compact. 0.38. What is the difference between the highest and the second highest Value added (% of GDP) in Brunei Darussalam?
Offer a terse response. 2.16. What is the difference between the highest and the second highest Value added (% of GDP) of Grenada?
Your response must be concise. 2.73. What is the difference between the highest and the lowest Value added (% of GDP) of Europe(developing only)?
Offer a terse response. 3.69. What is the difference between the highest and the lowest Value added (% of GDP) in Middle East & North Africa (all income levels)?
Provide a short and direct response. 3.62. What is the difference between the highest and the lowest Value added (% of GDP) of Brunei Darussalam?
Give a very brief answer. 8.51. What is the difference between the highest and the lowest Value added (% of GDP) of Grenada?
Offer a terse response. 7.65. 